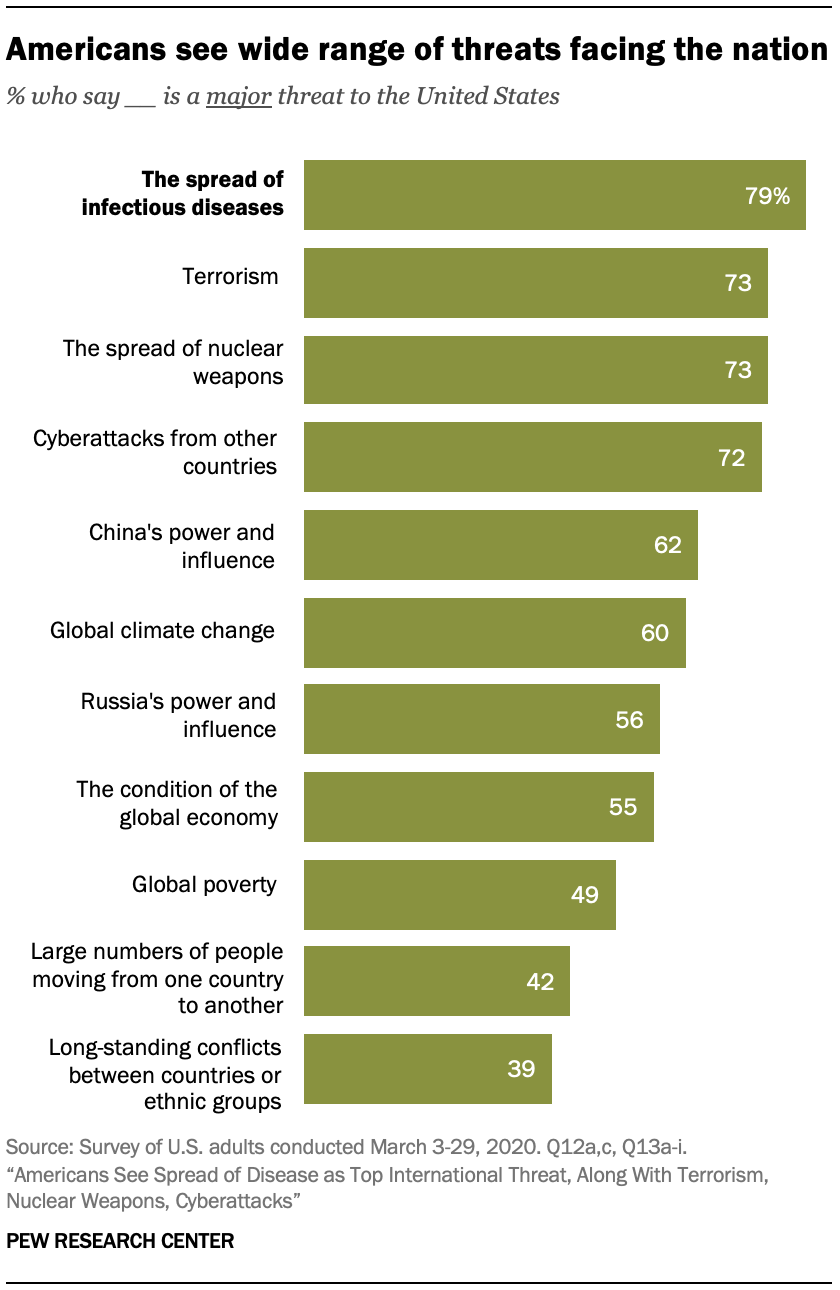Indicate a few pertinent items in this graphic. The threat of global climate change is not more significant than China's power and influence. The spread of infectious diseases poses the greatest threat to the national security of the United States. 